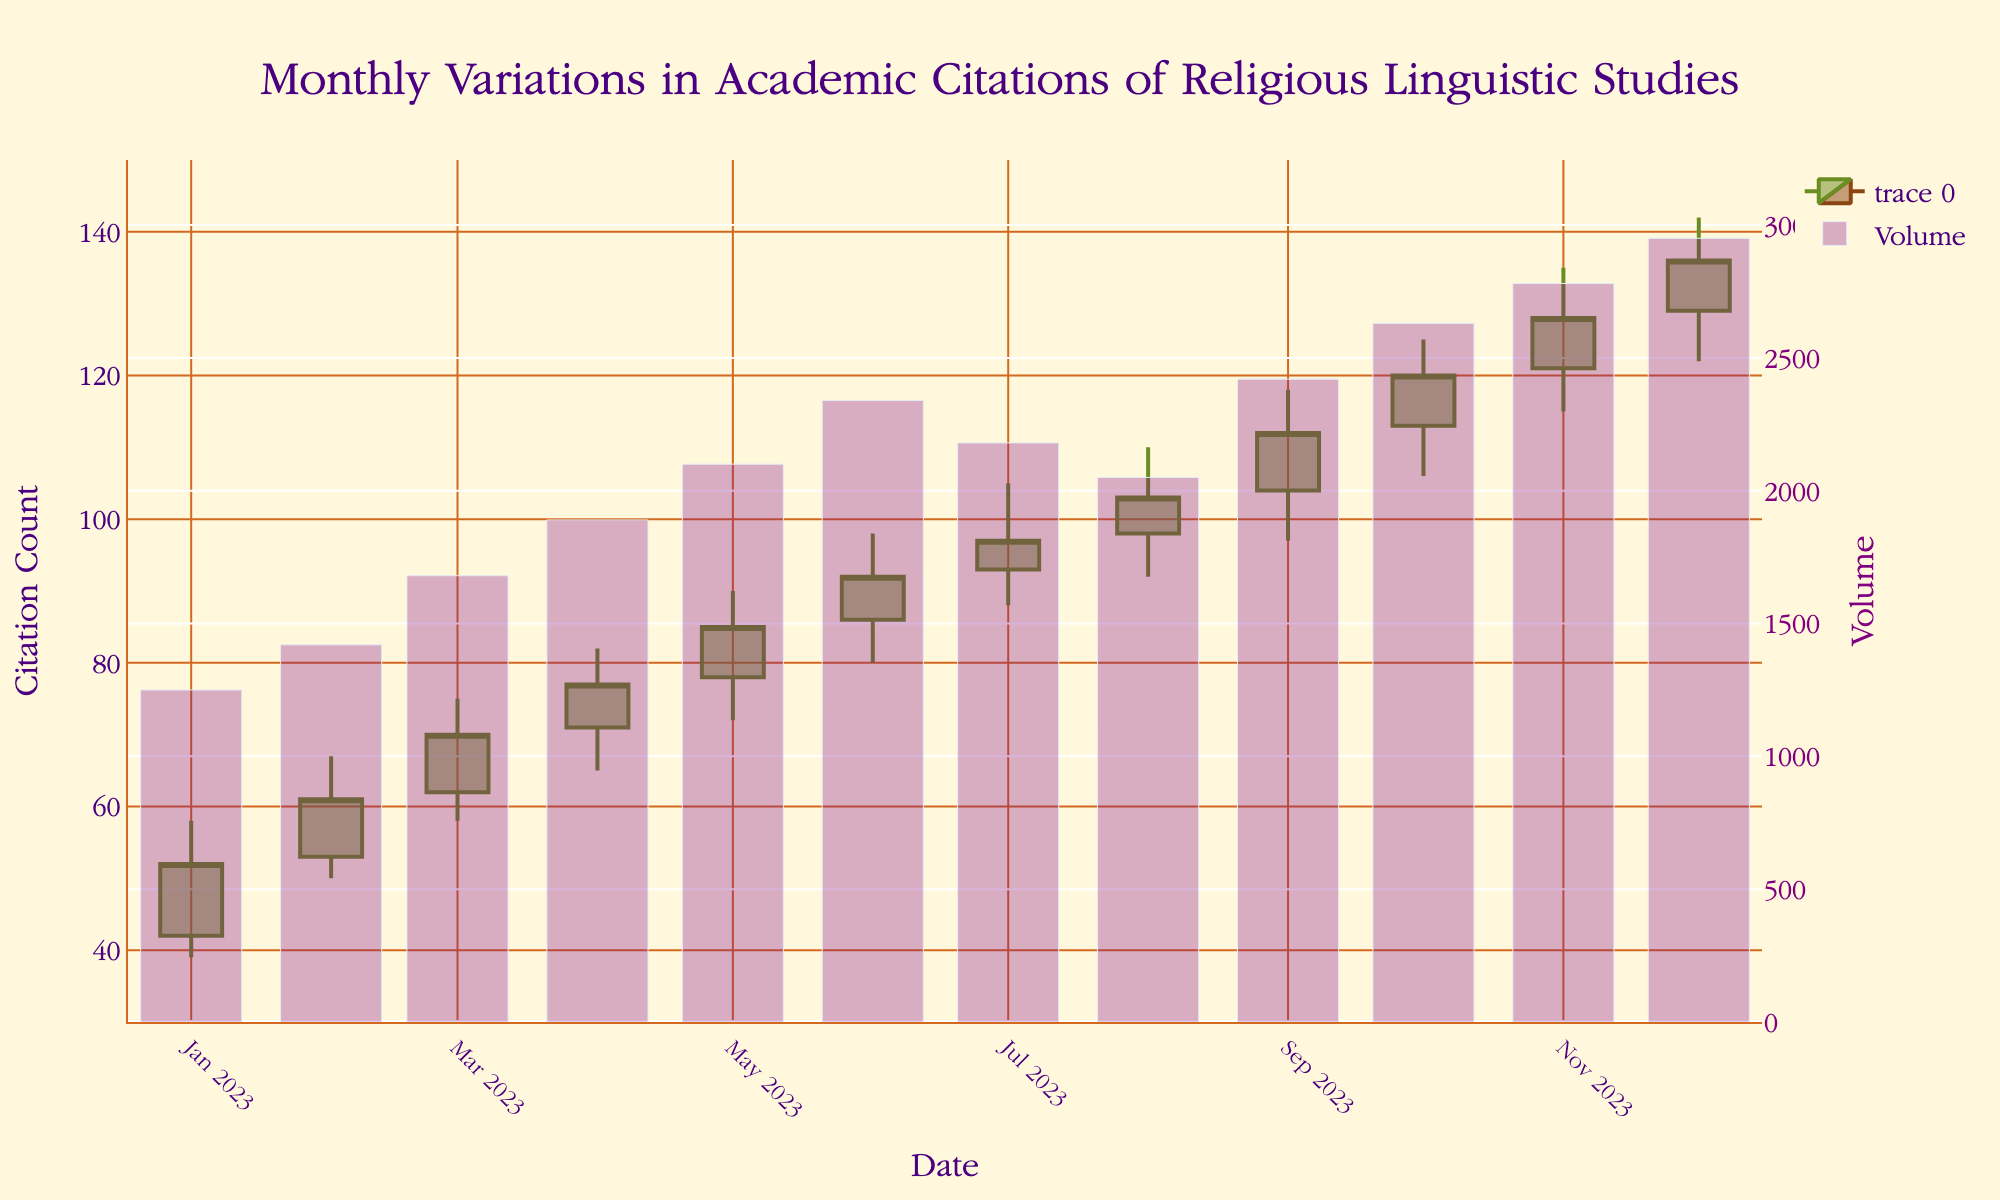What is the title of the chart? The title of the chart is displayed at the top and reads "Monthly Variations in Academic Citations of Religious Linguistic Studies".
Answer: Monthly Variations in Academic Citations of Religious Linguistic Studies What are the colors of the increasing and decreasing lines in the candlestick chart? The increasing lines are in olivedrab green, and the decreasing lines are in saddlebrown brown.
Answer: Olivedrab green and Saddlebrown brown How many citation data points are represented in the chart? There is one data point for each month of 2023, starting from January to December.
Answer: 12 What is the highest citation count recorded in any month of 2023? The highest citation count is represented by the "High" value in any month, which is 142 in December.
Answer: 142 What is the range of citation counts displayed on the y-axis? The y-axis range is displayed on the left side of the chart and goes from 30 to 150.
Answer: 30 to 150 How does the citation trend change from January to December? The citation trend generally increases from January with an open of 42 and closes at 52, to December with an open of 129 and closes at 136, showing a consistent rise.
Answer: Consistent rise Which month experienced the highest trading volume in academic citations? November experienced the highest volume with 2780 citations.
Answer: November What is the citation count at the close of July 2023? The closing citation count for July is represented by the "Close" value for that month, which is 97.
Answer: 97 Compare the opening and closing citation counts for February 2023. February's opening citation count is 53, and the closing citation count is 61, indicating an increase of 8 citations.
Answer: 53 to 61 What is the average closing citation count for the entire year? The closing values for each month must be summed and divided by 12. The calculation is (52 + 61 + 70 + 77 + 85 + 92 + 97 + 103 + 112 + 120 + 128 + 136) / 12, which is 96.
Answer: 96 